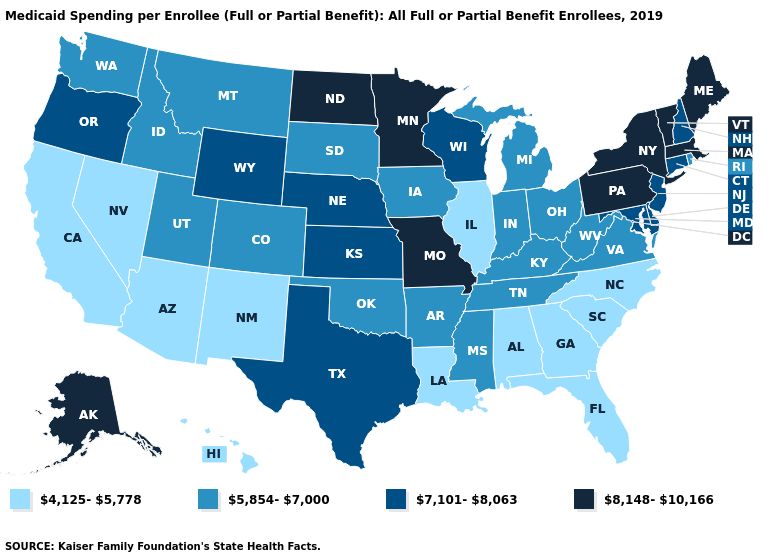Among the states that border Illinois , which have the lowest value?
Answer briefly. Indiana, Iowa, Kentucky. Among the states that border New Jersey , which have the highest value?
Answer briefly. New York, Pennsylvania. What is the value of Indiana?
Short answer required. 5,854-7,000. Which states have the highest value in the USA?
Concise answer only. Alaska, Maine, Massachusetts, Minnesota, Missouri, New York, North Dakota, Pennsylvania, Vermont. What is the value of Alabama?
Give a very brief answer. 4,125-5,778. What is the lowest value in states that border Washington?
Short answer required. 5,854-7,000. What is the value of Idaho?
Answer briefly. 5,854-7,000. Name the states that have a value in the range 8,148-10,166?
Write a very short answer. Alaska, Maine, Massachusetts, Minnesota, Missouri, New York, North Dakota, Pennsylvania, Vermont. Name the states that have a value in the range 7,101-8,063?
Answer briefly. Connecticut, Delaware, Kansas, Maryland, Nebraska, New Hampshire, New Jersey, Oregon, Texas, Wisconsin, Wyoming. What is the value of Florida?
Answer briefly. 4,125-5,778. What is the value of South Dakota?
Short answer required. 5,854-7,000. Name the states that have a value in the range 5,854-7,000?
Give a very brief answer. Arkansas, Colorado, Idaho, Indiana, Iowa, Kentucky, Michigan, Mississippi, Montana, Ohio, Oklahoma, Rhode Island, South Dakota, Tennessee, Utah, Virginia, Washington, West Virginia. Does North Carolina have the highest value in the USA?
Concise answer only. No. What is the lowest value in the South?
Give a very brief answer. 4,125-5,778. Among the states that border Rhode Island , does Connecticut have the highest value?
Quick response, please. No. 